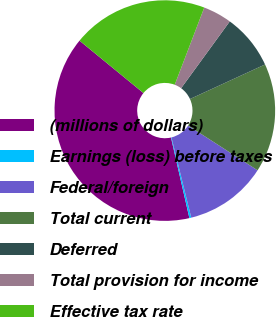Convert chart to OTSL. <chart><loc_0><loc_0><loc_500><loc_500><pie_chart><fcel>(millions of dollars)<fcel>Earnings (loss) before taxes<fcel>Federal/foreign<fcel>Total current<fcel>Deferred<fcel>Total provision for income<fcel>Effective tax rate<nl><fcel>39.5%<fcel>0.28%<fcel>12.04%<fcel>15.97%<fcel>8.12%<fcel>4.2%<fcel>19.89%<nl></chart> 